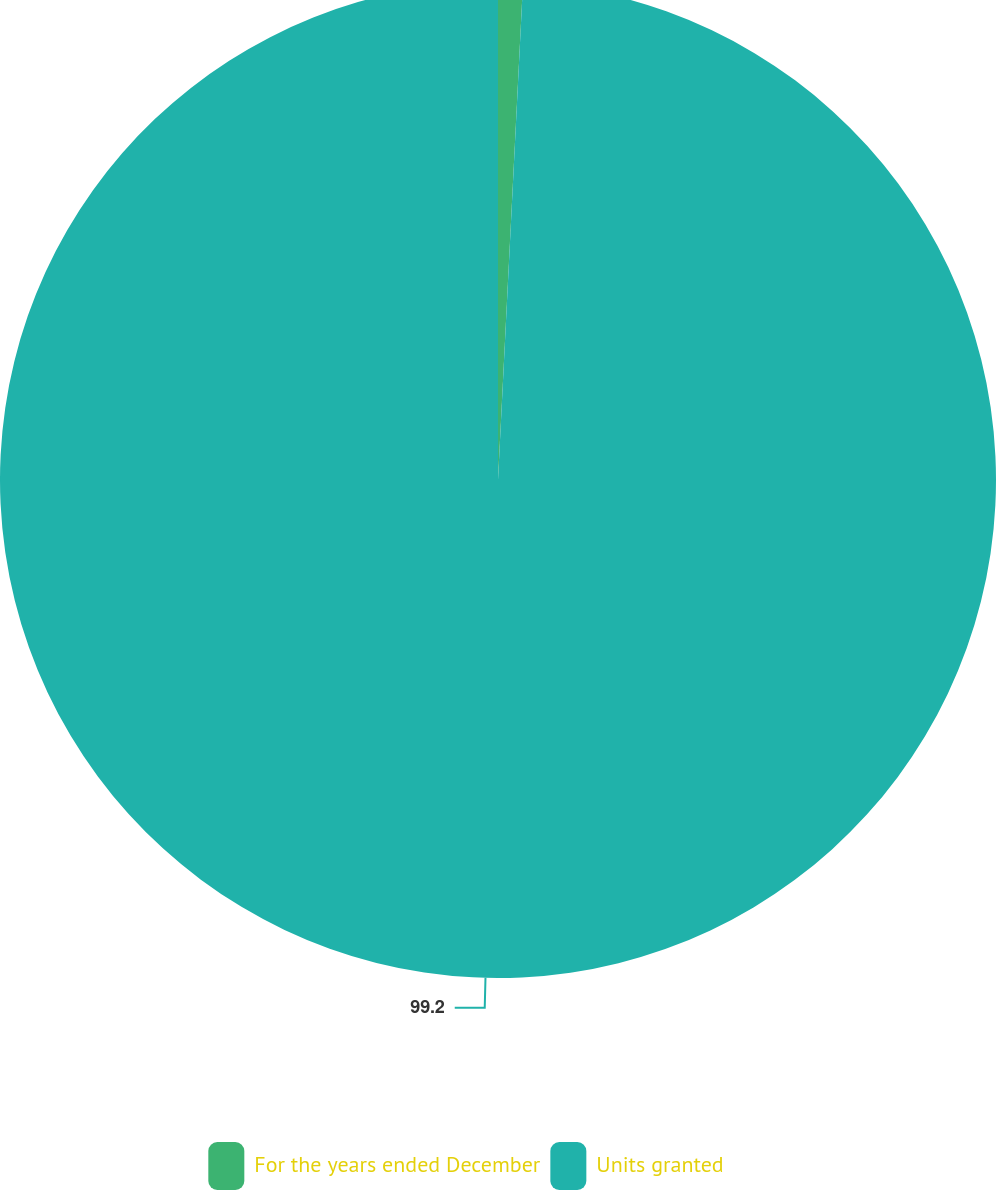Convert chart. <chart><loc_0><loc_0><loc_500><loc_500><pie_chart><fcel>For the years ended December<fcel>Units granted<nl><fcel>0.8%<fcel>99.2%<nl></chart> 